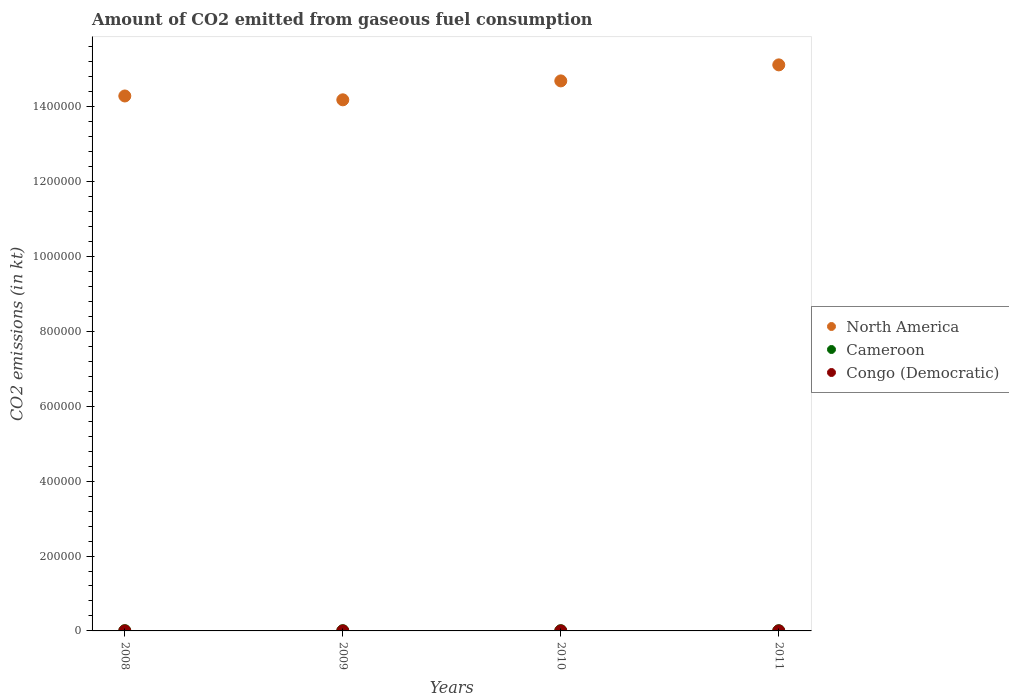How many different coloured dotlines are there?
Provide a succinct answer. 3. What is the amount of CO2 emitted in Cameroon in 2011?
Ensure brevity in your answer.  546.38. Across all years, what is the maximum amount of CO2 emitted in Congo (Democratic)?
Offer a terse response. 14.67. Across all years, what is the minimum amount of CO2 emitted in Congo (Democratic)?
Ensure brevity in your answer.  14.67. In which year was the amount of CO2 emitted in Congo (Democratic) maximum?
Ensure brevity in your answer.  2008. In which year was the amount of CO2 emitted in Congo (Democratic) minimum?
Offer a very short reply. 2008. What is the total amount of CO2 emitted in Cameroon in the graph?
Offer a very short reply. 2442.22. What is the difference between the amount of CO2 emitted in Congo (Democratic) in 2009 and that in 2011?
Provide a short and direct response. 0. What is the difference between the amount of CO2 emitted in North America in 2011 and the amount of CO2 emitted in Congo (Democratic) in 2010?
Provide a short and direct response. 1.51e+06. What is the average amount of CO2 emitted in Congo (Democratic) per year?
Your response must be concise. 14.67. In the year 2011, what is the difference between the amount of CO2 emitted in Congo (Democratic) and amount of CO2 emitted in North America?
Provide a short and direct response. -1.51e+06. Is the amount of CO2 emitted in Congo (Democratic) in 2009 less than that in 2010?
Ensure brevity in your answer.  No. What is the difference between the highest and the second highest amount of CO2 emitted in Congo (Democratic)?
Provide a short and direct response. 0. What is the difference between the highest and the lowest amount of CO2 emitted in North America?
Provide a succinct answer. 9.33e+04. In how many years, is the amount of CO2 emitted in Cameroon greater than the average amount of CO2 emitted in Cameroon taken over all years?
Your answer should be very brief. 1. Is the amount of CO2 emitted in Cameroon strictly less than the amount of CO2 emitted in Congo (Democratic) over the years?
Your response must be concise. No. How many years are there in the graph?
Give a very brief answer. 4. What is the difference between two consecutive major ticks on the Y-axis?
Provide a short and direct response. 2.00e+05. Are the values on the major ticks of Y-axis written in scientific E-notation?
Your answer should be very brief. No. Does the graph contain any zero values?
Your answer should be very brief. No. Where does the legend appear in the graph?
Your answer should be compact. Center right. How are the legend labels stacked?
Offer a terse response. Vertical. What is the title of the graph?
Your answer should be compact. Amount of CO2 emitted from gaseous fuel consumption. Does "Mali" appear as one of the legend labels in the graph?
Your response must be concise. No. What is the label or title of the Y-axis?
Provide a short and direct response. CO2 emissions (in kt). What is the CO2 emissions (in kt) of North America in 2008?
Make the answer very short. 1.43e+06. What is the CO2 emissions (in kt) of Cameroon in 2008?
Offer a very short reply. 711.4. What is the CO2 emissions (in kt) of Congo (Democratic) in 2008?
Give a very brief answer. 14.67. What is the CO2 emissions (in kt) in North America in 2009?
Give a very brief answer. 1.42e+06. What is the CO2 emissions (in kt) of Cameroon in 2009?
Make the answer very short. 590.39. What is the CO2 emissions (in kt) of Congo (Democratic) in 2009?
Offer a terse response. 14.67. What is the CO2 emissions (in kt) in North America in 2010?
Provide a short and direct response. 1.47e+06. What is the CO2 emissions (in kt) in Cameroon in 2010?
Make the answer very short. 594.05. What is the CO2 emissions (in kt) of Congo (Democratic) in 2010?
Keep it short and to the point. 14.67. What is the CO2 emissions (in kt) in North America in 2011?
Your answer should be very brief. 1.51e+06. What is the CO2 emissions (in kt) of Cameroon in 2011?
Keep it short and to the point. 546.38. What is the CO2 emissions (in kt) of Congo (Democratic) in 2011?
Give a very brief answer. 14.67. Across all years, what is the maximum CO2 emissions (in kt) of North America?
Give a very brief answer. 1.51e+06. Across all years, what is the maximum CO2 emissions (in kt) in Cameroon?
Your answer should be compact. 711.4. Across all years, what is the maximum CO2 emissions (in kt) of Congo (Democratic)?
Give a very brief answer. 14.67. Across all years, what is the minimum CO2 emissions (in kt) of North America?
Keep it short and to the point. 1.42e+06. Across all years, what is the minimum CO2 emissions (in kt) of Cameroon?
Provide a succinct answer. 546.38. Across all years, what is the minimum CO2 emissions (in kt) of Congo (Democratic)?
Your answer should be compact. 14.67. What is the total CO2 emissions (in kt) in North America in the graph?
Your response must be concise. 5.83e+06. What is the total CO2 emissions (in kt) in Cameroon in the graph?
Your answer should be very brief. 2442.22. What is the total CO2 emissions (in kt) of Congo (Democratic) in the graph?
Offer a terse response. 58.67. What is the difference between the CO2 emissions (in kt) in North America in 2008 and that in 2009?
Make the answer very short. 1.03e+04. What is the difference between the CO2 emissions (in kt) of Cameroon in 2008 and that in 2009?
Offer a terse response. 121.01. What is the difference between the CO2 emissions (in kt) in Congo (Democratic) in 2008 and that in 2009?
Offer a very short reply. 0. What is the difference between the CO2 emissions (in kt) in North America in 2008 and that in 2010?
Keep it short and to the point. -4.03e+04. What is the difference between the CO2 emissions (in kt) in Cameroon in 2008 and that in 2010?
Offer a very short reply. 117.34. What is the difference between the CO2 emissions (in kt) of Congo (Democratic) in 2008 and that in 2010?
Ensure brevity in your answer.  0. What is the difference between the CO2 emissions (in kt) in North America in 2008 and that in 2011?
Offer a terse response. -8.31e+04. What is the difference between the CO2 emissions (in kt) of Cameroon in 2008 and that in 2011?
Provide a succinct answer. 165.01. What is the difference between the CO2 emissions (in kt) in Congo (Democratic) in 2008 and that in 2011?
Your answer should be very brief. 0. What is the difference between the CO2 emissions (in kt) of North America in 2009 and that in 2010?
Your answer should be compact. -5.05e+04. What is the difference between the CO2 emissions (in kt) of Cameroon in 2009 and that in 2010?
Provide a succinct answer. -3.67. What is the difference between the CO2 emissions (in kt) of North America in 2009 and that in 2011?
Give a very brief answer. -9.33e+04. What is the difference between the CO2 emissions (in kt) in Cameroon in 2009 and that in 2011?
Make the answer very short. 44. What is the difference between the CO2 emissions (in kt) in Congo (Democratic) in 2009 and that in 2011?
Your answer should be compact. 0. What is the difference between the CO2 emissions (in kt) of North America in 2010 and that in 2011?
Offer a very short reply. -4.28e+04. What is the difference between the CO2 emissions (in kt) in Cameroon in 2010 and that in 2011?
Give a very brief answer. 47.67. What is the difference between the CO2 emissions (in kt) in Congo (Democratic) in 2010 and that in 2011?
Offer a very short reply. 0. What is the difference between the CO2 emissions (in kt) in North America in 2008 and the CO2 emissions (in kt) in Cameroon in 2009?
Offer a very short reply. 1.43e+06. What is the difference between the CO2 emissions (in kt) in North America in 2008 and the CO2 emissions (in kt) in Congo (Democratic) in 2009?
Provide a short and direct response. 1.43e+06. What is the difference between the CO2 emissions (in kt) of Cameroon in 2008 and the CO2 emissions (in kt) of Congo (Democratic) in 2009?
Ensure brevity in your answer.  696.73. What is the difference between the CO2 emissions (in kt) in North America in 2008 and the CO2 emissions (in kt) in Cameroon in 2010?
Provide a short and direct response. 1.43e+06. What is the difference between the CO2 emissions (in kt) in North America in 2008 and the CO2 emissions (in kt) in Congo (Democratic) in 2010?
Offer a terse response. 1.43e+06. What is the difference between the CO2 emissions (in kt) of Cameroon in 2008 and the CO2 emissions (in kt) of Congo (Democratic) in 2010?
Give a very brief answer. 696.73. What is the difference between the CO2 emissions (in kt) of North America in 2008 and the CO2 emissions (in kt) of Cameroon in 2011?
Provide a succinct answer. 1.43e+06. What is the difference between the CO2 emissions (in kt) of North America in 2008 and the CO2 emissions (in kt) of Congo (Democratic) in 2011?
Offer a terse response. 1.43e+06. What is the difference between the CO2 emissions (in kt) in Cameroon in 2008 and the CO2 emissions (in kt) in Congo (Democratic) in 2011?
Offer a terse response. 696.73. What is the difference between the CO2 emissions (in kt) of North America in 2009 and the CO2 emissions (in kt) of Cameroon in 2010?
Offer a terse response. 1.42e+06. What is the difference between the CO2 emissions (in kt) in North America in 2009 and the CO2 emissions (in kt) in Congo (Democratic) in 2010?
Your response must be concise. 1.42e+06. What is the difference between the CO2 emissions (in kt) of Cameroon in 2009 and the CO2 emissions (in kt) of Congo (Democratic) in 2010?
Provide a short and direct response. 575.72. What is the difference between the CO2 emissions (in kt) in North America in 2009 and the CO2 emissions (in kt) in Cameroon in 2011?
Your response must be concise. 1.42e+06. What is the difference between the CO2 emissions (in kt) of North America in 2009 and the CO2 emissions (in kt) of Congo (Democratic) in 2011?
Provide a short and direct response. 1.42e+06. What is the difference between the CO2 emissions (in kt) in Cameroon in 2009 and the CO2 emissions (in kt) in Congo (Democratic) in 2011?
Provide a succinct answer. 575.72. What is the difference between the CO2 emissions (in kt) of North America in 2010 and the CO2 emissions (in kt) of Cameroon in 2011?
Your answer should be compact. 1.47e+06. What is the difference between the CO2 emissions (in kt) of North America in 2010 and the CO2 emissions (in kt) of Congo (Democratic) in 2011?
Keep it short and to the point. 1.47e+06. What is the difference between the CO2 emissions (in kt) of Cameroon in 2010 and the CO2 emissions (in kt) of Congo (Democratic) in 2011?
Give a very brief answer. 579.39. What is the average CO2 emissions (in kt) of North America per year?
Offer a very short reply. 1.46e+06. What is the average CO2 emissions (in kt) of Cameroon per year?
Keep it short and to the point. 610.56. What is the average CO2 emissions (in kt) in Congo (Democratic) per year?
Provide a succinct answer. 14.67. In the year 2008, what is the difference between the CO2 emissions (in kt) in North America and CO2 emissions (in kt) in Cameroon?
Your response must be concise. 1.43e+06. In the year 2008, what is the difference between the CO2 emissions (in kt) of North America and CO2 emissions (in kt) of Congo (Democratic)?
Keep it short and to the point. 1.43e+06. In the year 2008, what is the difference between the CO2 emissions (in kt) in Cameroon and CO2 emissions (in kt) in Congo (Democratic)?
Your answer should be very brief. 696.73. In the year 2009, what is the difference between the CO2 emissions (in kt) in North America and CO2 emissions (in kt) in Cameroon?
Your answer should be very brief. 1.42e+06. In the year 2009, what is the difference between the CO2 emissions (in kt) in North America and CO2 emissions (in kt) in Congo (Democratic)?
Offer a terse response. 1.42e+06. In the year 2009, what is the difference between the CO2 emissions (in kt) in Cameroon and CO2 emissions (in kt) in Congo (Democratic)?
Your response must be concise. 575.72. In the year 2010, what is the difference between the CO2 emissions (in kt) of North America and CO2 emissions (in kt) of Cameroon?
Provide a short and direct response. 1.47e+06. In the year 2010, what is the difference between the CO2 emissions (in kt) of North America and CO2 emissions (in kt) of Congo (Democratic)?
Give a very brief answer. 1.47e+06. In the year 2010, what is the difference between the CO2 emissions (in kt) in Cameroon and CO2 emissions (in kt) in Congo (Democratic)?
Provide a succinct answer. 579.39. In the year 2011, what is the difference between the CO2 emissions (in kt) in North America and CO2 emissions (in kt) in Cameroon?
Make the answer very short. 1.51e+06. In the year 2011, what is the difference between the CO2 emissions (in kt) of North America and CO2 emissions (in kt) of Congo (Democratic)?
Provide a succinct answer. 1.51e+06. In the year 2011, what is the difference between the CO2 emissions (in kt) in Cameroon and CO2 emissions (in kt) in Congo (Democratic)?
Provide a short and direct response. 531.72. What is the ratio of the CO2 emissions (in kt) of North America in 2008 to that in 2009?
Give a very brief answer. 1.01. What is the ratio of the CO2 emissions (in kt) in Cameroon in 2008 to that in 2009?
Offer a very short reply. 1.21. What is the ratio of the CO2 emissions (in kt) of Congo (Democratic) in 2008 to that in 2009?
Offer a terse response. 1. What is the ratio of the CO2 emissions (in kt) of North America in 2008 to that in 2010?
Offer a terse response. 0.97. What is the ratio of the CO2 emissions (in kt) in Cameroon in 2008 to that in 2010?
Offer a terse response. 1.2. What is the ratio of the CO2 emissions (in kt) of North America in 2008 to that in 2011?
Provide a succinct answer. 0.95. What is the ratio of the CO2 emissions (in kt) of Cameroon in 2008 to that in 2011?
Keep it short and to the point. 1.3. What is the ratio of the CO2 emissions (in kt) of North America in 2009 to that in 2010?
Your answer should be compact. 0.97. What is the ratio of the CO2 emissions (in kt) in North America in 2009 to that in 2011?
Give a very brief answer. 0.94. What is the ratio of the CO2 emissions (in kt) of Cameroon in 2009 to that in 2011?
Give a very brief answer. 1.08. What is the ratio of the CO2 emissions (in kt) in Congo (Democratic) in 2009 to that in 2011?
Ensure brevity in your answer.  1. What is the ratio of the CO2 emissions (in kt) in North America in 2010 to that in 2011?
Offer a terse response. 0.97. What is the ratio of the CO2 emissions (in kt) in Cameroon in 2010 to that in 2011?
Offer a very short reply. 1.09. What is the ratio of the CO2 emissions (in kt) of Congo (Democratic) in 2010 to that in 2011?
Make the answer very short. 1. What is the difference between the highest and the second highest CO2 emissions (in kt) of North America?
Keep it short and to the point. 4.28e+04. What is the difference between the highest and the second highest CO2 emissions (in kt) in Cameroon?
Give a very brief answer. 117.34. What is the difference between the highest and the lowest CO2 emissions (in kt) in North America?
Provide a succinct answer. 9.33e+04. What is the difference between the highest and the lowest CO2 emissions (in kt) of Cameroon?
Offer a terse response. 165.01. What is the difference between the highest and the lowest CO2 emissions (in kt) of Congo (Democratic)?
Your answer should be very brief. 0. 